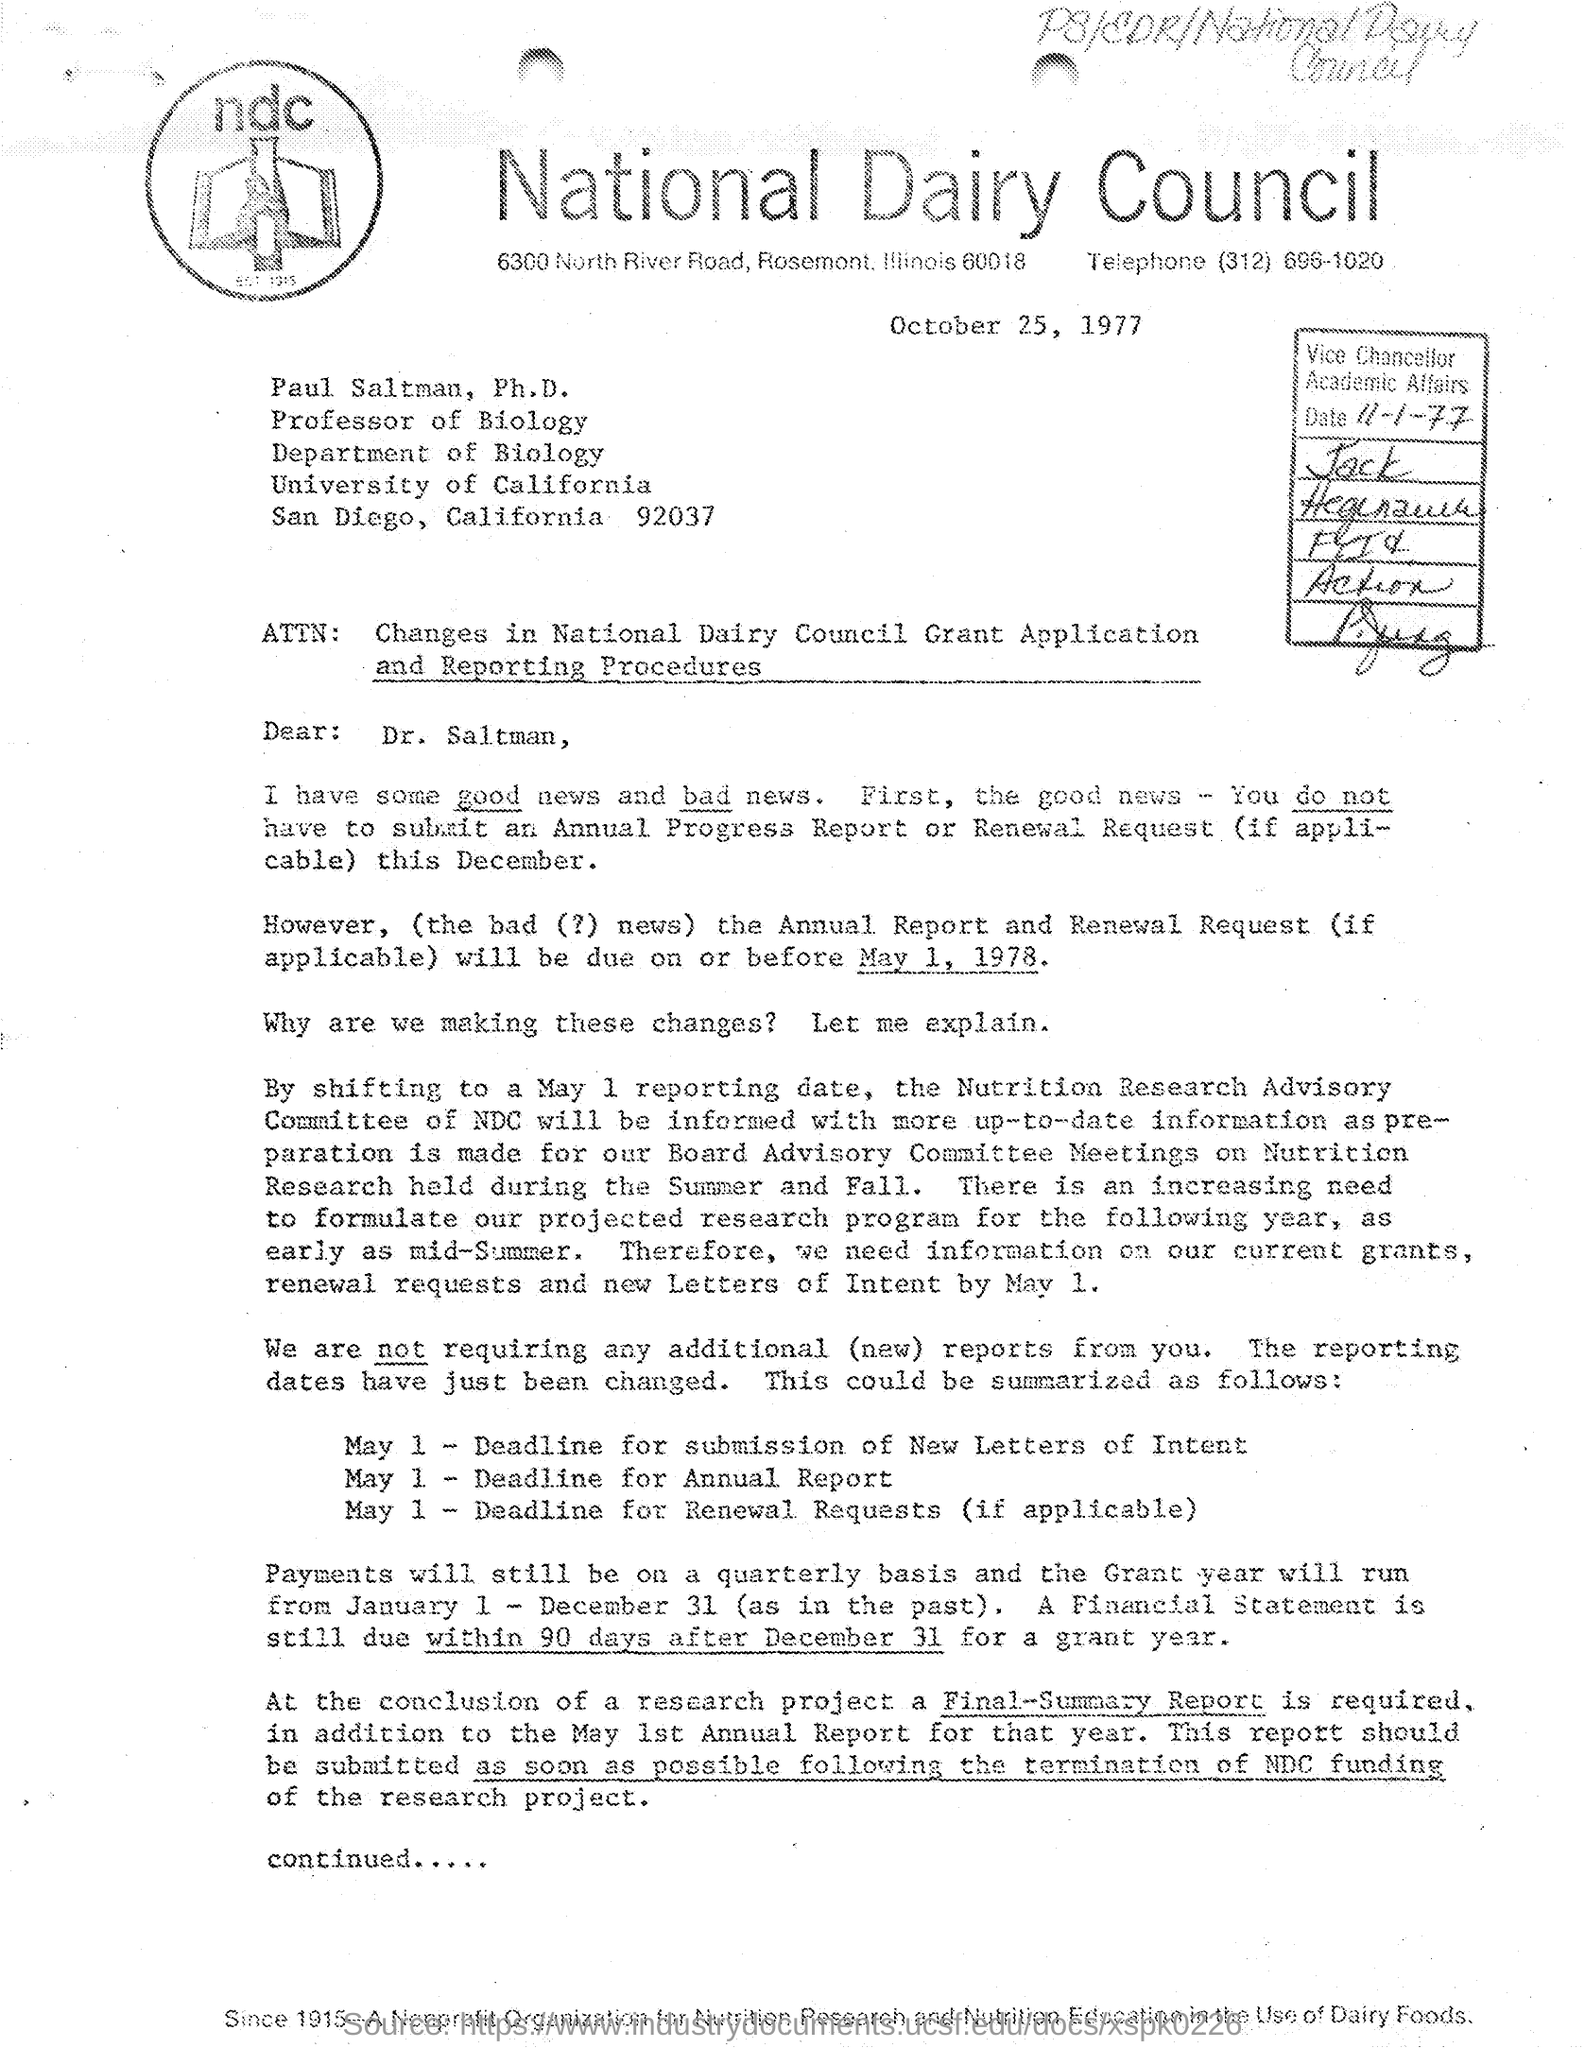List a handful of essential elements in this visual. The National Dairy Council, commonly abbreviated as NDC, is a government-supported organization dedicated to promoting the agricultural development and growth of the dairy industry. The phone number of the application is (312) 696-1020. The date written on the application is October 25, 1977. 